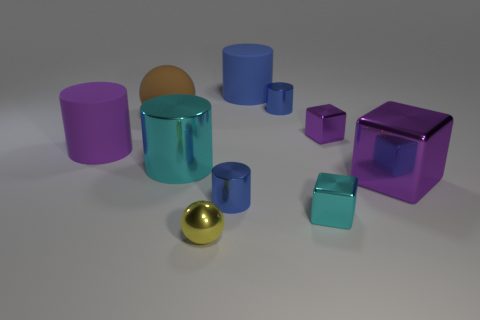Do the brown object and the yellow shiny object have the same size?
Provide a succinct answer. No. There is a shiny thing that is on the right side of the small cyan metallic block and behind the big metal block; what is its size?
Offer a terse response. Small. The metallic thing that is the same color as the large block is what shape?
Make the answer very short. Cube. Are there any yellow metallic things that have the same shape as the brown object?
Your answer should be compact. Yes. There is a large rubber object that is on the right side of the cyan metallic object that is to the left of the cyan object to the right of the yellow object; what shape is it?
Offer a terse response. Cylinder. Does the small yellow object have the same shape as the big brown rubber thing that is behind the large purple rubber thing?
Your response must be concise. Yes. What number of small things are either cylinders or blue metal cylinders?
Make the answer very short. 2. Is there a ball of the same size as the cyan cube?
Your response must be concise. Yes. What is the color of the shiny cylinder behind the large shiny object that is left of the blue thing in front of the cyan metal cylinder?
Offer a terse response. Blue. Does the brown thing have the same material as the large purple object that is on the left side of the yellow thing?
Your answer should be compact. Yes. 